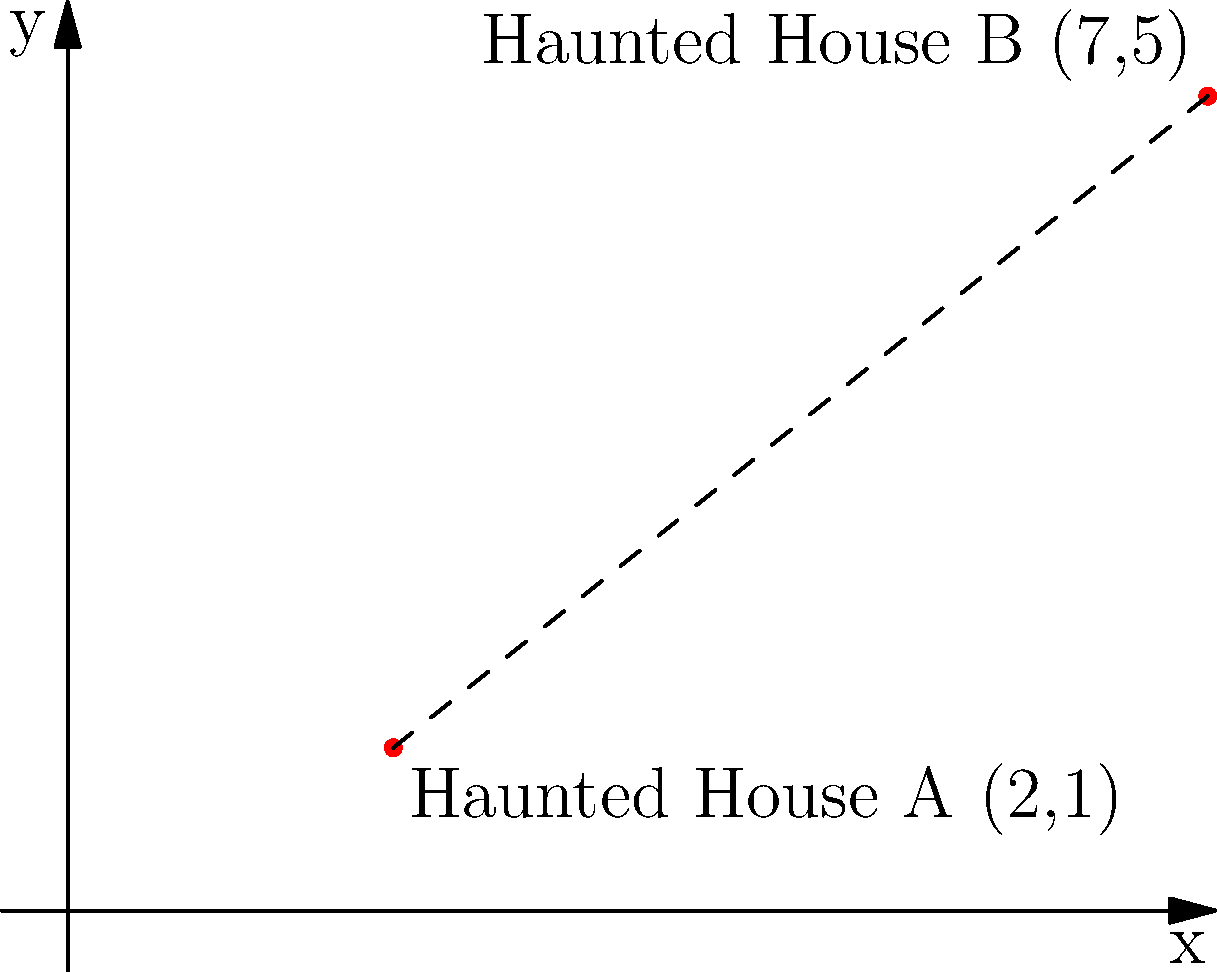In the spooky town of Goosebump Grove, two haunted houses are located on a Cartesian grid. Haunted House A is at coordinates (2,1), and Haunted House B is at coordinates (7,5). What is the shortest distance between these two haunted houses? To find the shortest distance between two points on a Cartesian grid, we can use the distance formula, which is derived from the Pythagorean theorem:

$$d = \sqrt{(x_2 - x_1)^2 + (y_2 - y_1)^2}$$

Where $(x_1, y_1)$ are the coordinates of the first point and $(x_2, y_2)$ are the coordinates of the second point.

Let's plug in our values:
* Haunted House A: $(x_1, y_1) = (2, 1)$
* Haunted House B: $(x_2, y_2) = (7, 5)$

Now, let's calculate:

1) $d = \sqrt{(7 - 2)^2 + (5 - 1)^2}$

2) $d = \sqrt{5^2 + 4^2}$

3) $d = \sqrt{25 + 16}$

4) $d = \sqrt{41}$

5) $d \approx 6.40$ (rounded to two decimal places)

Therefore, the shortest distance between the two haunted houses is $\sqrt{41}$ units, or approximately 6.40 units.
Answer: $\sqrt{41}$ units 